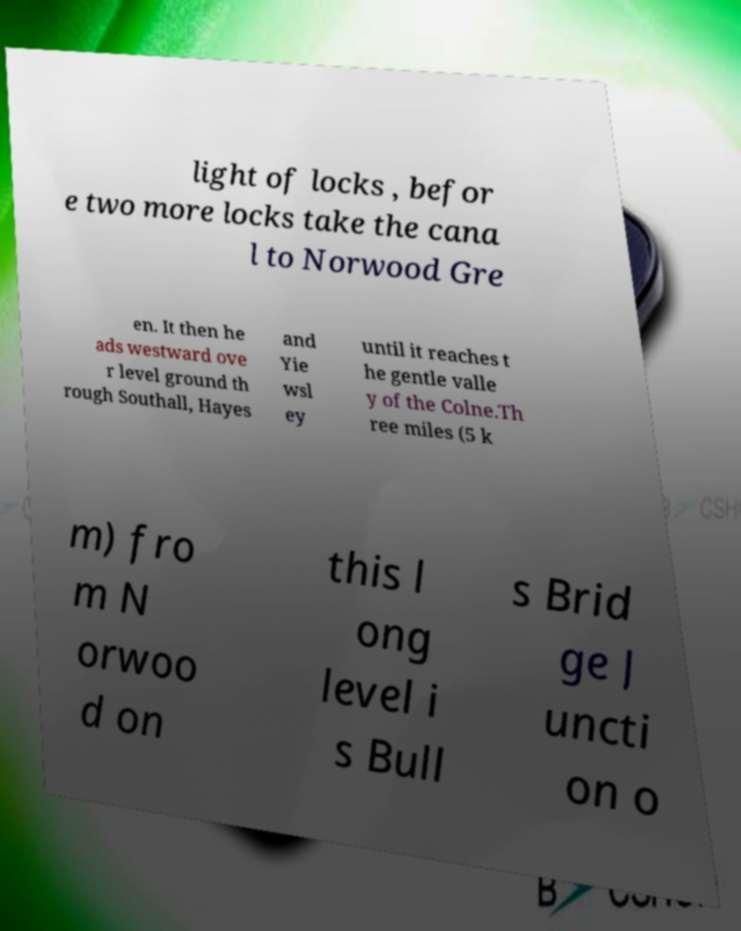Can you accurately transcribe the text from the provided image for me? light of locks , befor e two more locks take the cana l to Norwood Gre en. It then he ads westward ove r level ground th rough Southall, Hayes and Yie wsl ey until it reaches t he gentle valle y of the Colne.Th ree miles (5 k m) fro m N orwoo d on this l ong level i s Bull s Brid ge J uncti on o 